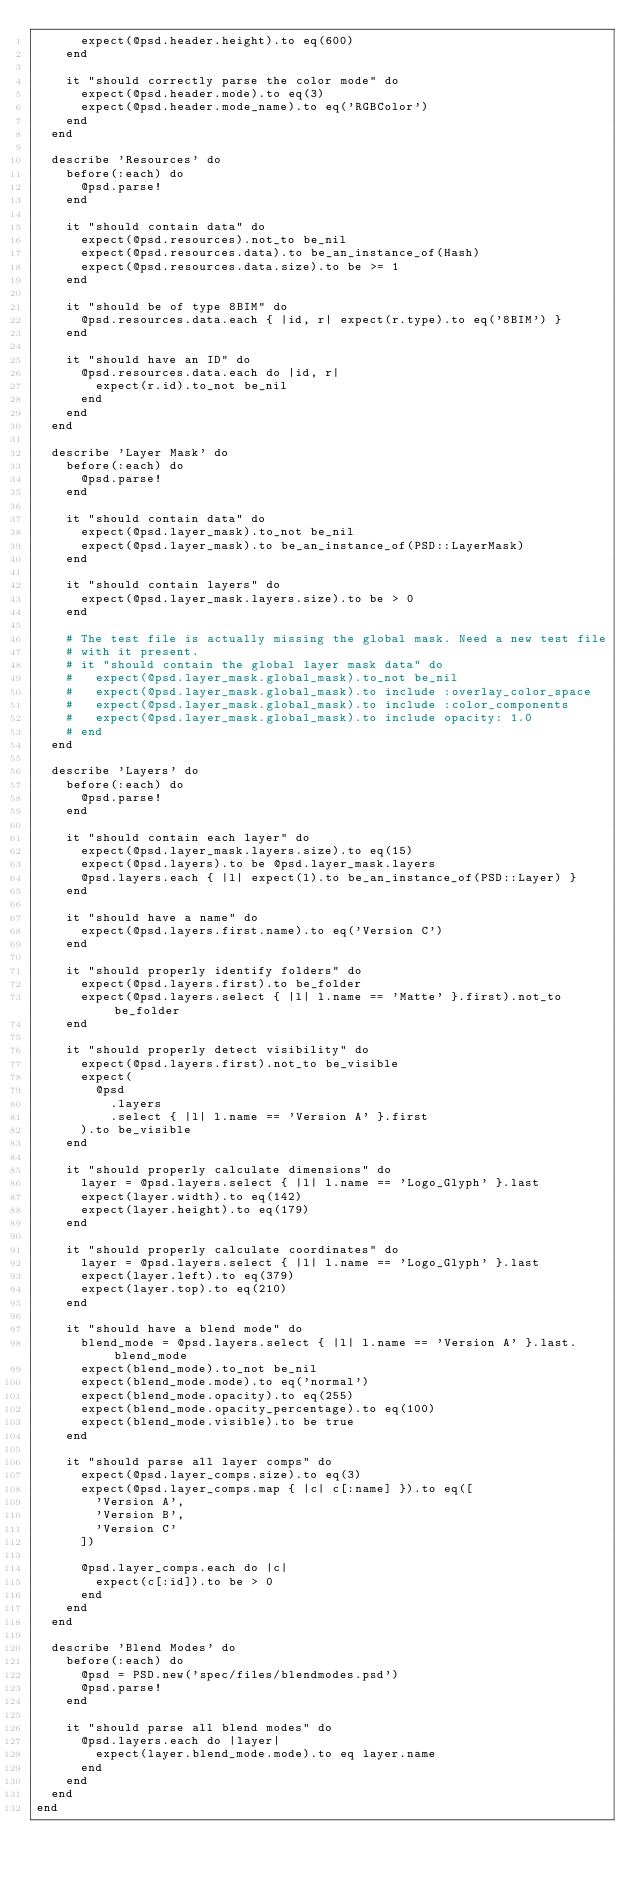<code> <loc_0><loc_0><loc_500><loc_500><_Ruby_>      expect(@psd.header.height).to eq(600)
    end

    it "should correctly parse the color mode" do
      expect(@psd.header.mode).to eq(3)
      expect(@psd.header.mode_name).to eq('RGBColor')
    end
  end

  describe 'Resources' do
    before(:each) do
      @psd.parse!
    end

    it "should contain data" do
      expect(@psd.resources).not_to be_nil
      expect(@psd.resources.data).to be_an_instance_of(Hash)
      expect(@psd.resources.data.size).to be >= 1
    end

    it "should be of type 8BIM" do
      @psd.resources.data.each { |id, r| expect(r.type).to eq('8BIM') }
    end

    it "should have an ID" do
      @psd.resources.data.each do |id, r|
        expect(r.id).to_not be_nil
      end
    end
  end

  describe 'Layer Mask' do
    before(:each) do
      @psd.parse!
    end

    it "should contain data" do
      expect(@psd.layer_mask).to_not be_nil
      expect(@psd.layer_mask).to be_an_instance_of(PSD::LayerMask)
    end

    it "should contain layers" do
      expect(@psd.layer_mask.layers.size).to be > 0
    end

    # The test file is actually missing the global mask. Need a new test file
    # with it present.
    # it "should contain the global layer mask data" do
    #   expect(@psd.layer_mask.global_mask).to_not be_nil
    #   expect(@psd.layer_mask.global_mask).to include :overlay_color_space
    #   expect(@psd.layer_mask.global_mask).to include :color_components
    #   expect(@psd.layer_mask.global_mask).to include opacity: 1.0
    # end
  end

  describe 'Layers' do
    before(:each) do
      @psd.parse!
    end

    it "should contain each layer" do
      expect(@psd.layer_mask.layers.size).to eq(15)
      expect(@psd.layers).to be @psd.layer_mask.layers
      @psd.layers.each { |l| expect(l).to be_an_instance_of(PSD::Layer) }
    end

    it "should have a name" do
      expect(@psd.layers.first.name).to eq('Version C')
    end

    it "should properly identify folders" do
      expect(@psd.layers.first).to be_folder
      expect(@psd.layers.select { |l| l.name == 'Matte' }.first).not_to be_folder
    end

    it "should properly detect visibility" do
      expect(@psd.layers.first).not_to be_visible
      expect(
        @psd
          .layers
          .select { |l| l.name == 'Version A' }.first
      ).to be_visible
    end

    it "should properly calculate dimensions" do
      layer = @psd.layers.select { |l| l.name == 'Logo_Glyph' }.last
      expect(layer.width).to eq(142)
      expect(layer.height).to eq(179)
    end

    it "should properly calculate coordinates" do
      layer = @psd.layers.select { |l| l.name == 'Logo_Glyph' }.last
      expect(layer.left).to eq(379)
      expect(layer.top).to eq(210)
    end

    it "should have a blend mode" do
      blend_mode = @psd.layers.select { |l| l.name == 'Version A' }.last.blend_mode
      expect(blend_mode).to_not be_nil
      expect(blend_mode.mode).to eq('normal')
      expect(blend_mode.opacity).to eq(255)
      expect(blend_mode.opacity_percentage).to eq(100)
      expect(blend_mode.visible).to be true
    end

    it "should parse all layer comps" do
      expect(@psd.layer_comps.size).to eq(3)
      expect(@psd.layer_comps.map { |c| c[:name] }).to eq([
        'Version A',
        'Version B',
        'Version C'
      ])

      @psd.layer_comps.each do |c|
        expect(c[:id]).to be > 0
      end
    end
  end
  
  describe 'Blend Modes' do
    before(:each) do
      @psd = PSD.new('spec/files/blendmodes.psd')
      @psd.parse!
    end

    it "should parse all blend modes" do
      @psd.layers.each do |layer|
        expect(layer.blend_mode.mode).to eq layer.name
      end      
    end
  end  
end</code> 